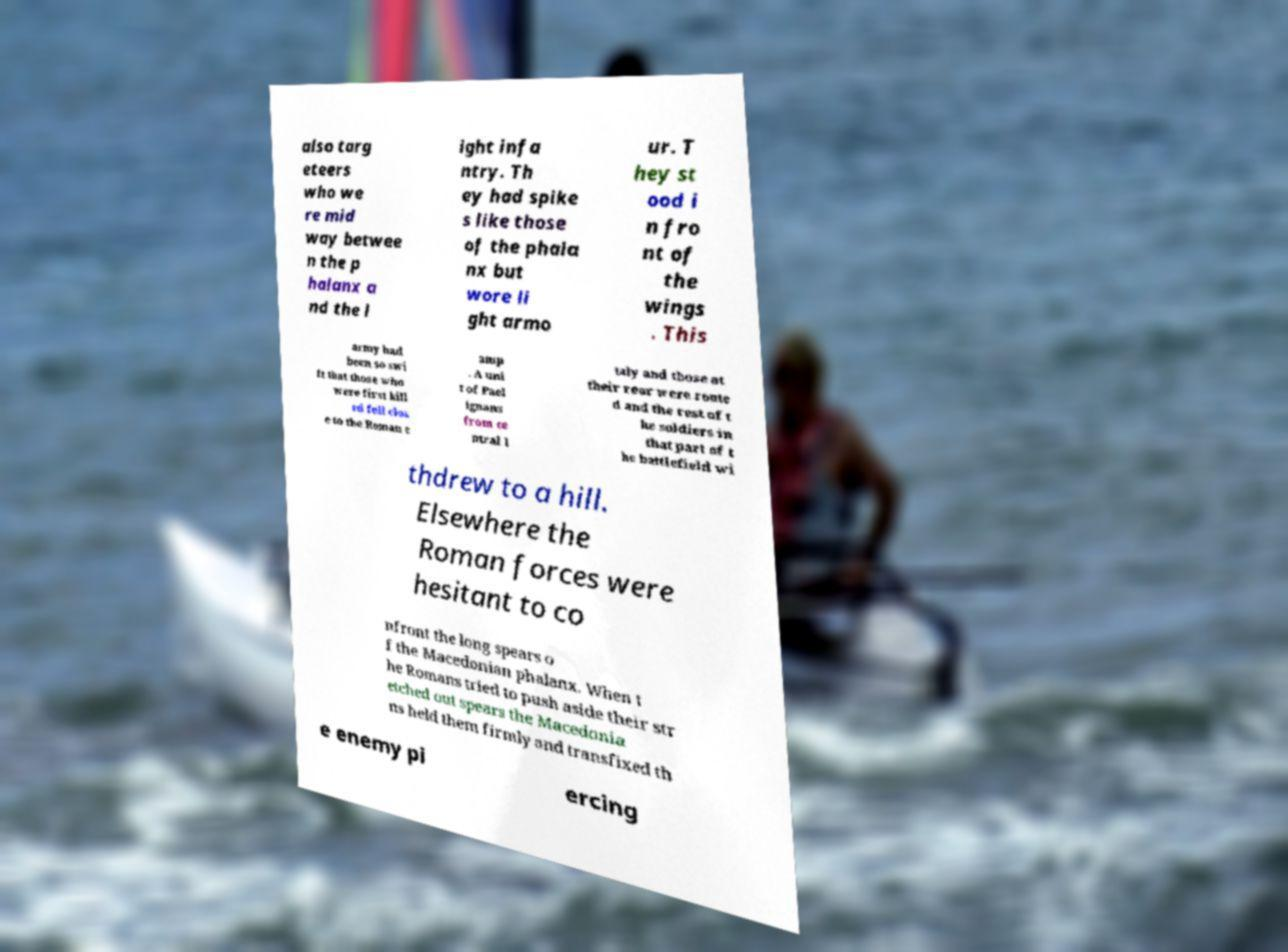Can you accurately transcribe the text from the provided image for me? also targ eteers who we re mid way betwee n the p halanx a nd the l ight infa ntry. Th ey had spike s like those of the phala nx but wore li ght armo ur. T hey st ood i n fro nt of the wings . This army had been so swi ft that those who were first kill ed fell clos e to the Roman c amp . A uni t of Pael ignans from ce ntral I taly and those at their rear were route d and the rest of t he soldiers in that part of t he battlefield wi thdrew to a hill. Elsewhere the Roman forces were hesitant to co nfront the long spears o f the Macedonian phalanx. When t he Romans tried to push aside their str etched out spears the Macedonia ns held them firmly and transfixed th e enemy pi ercing 